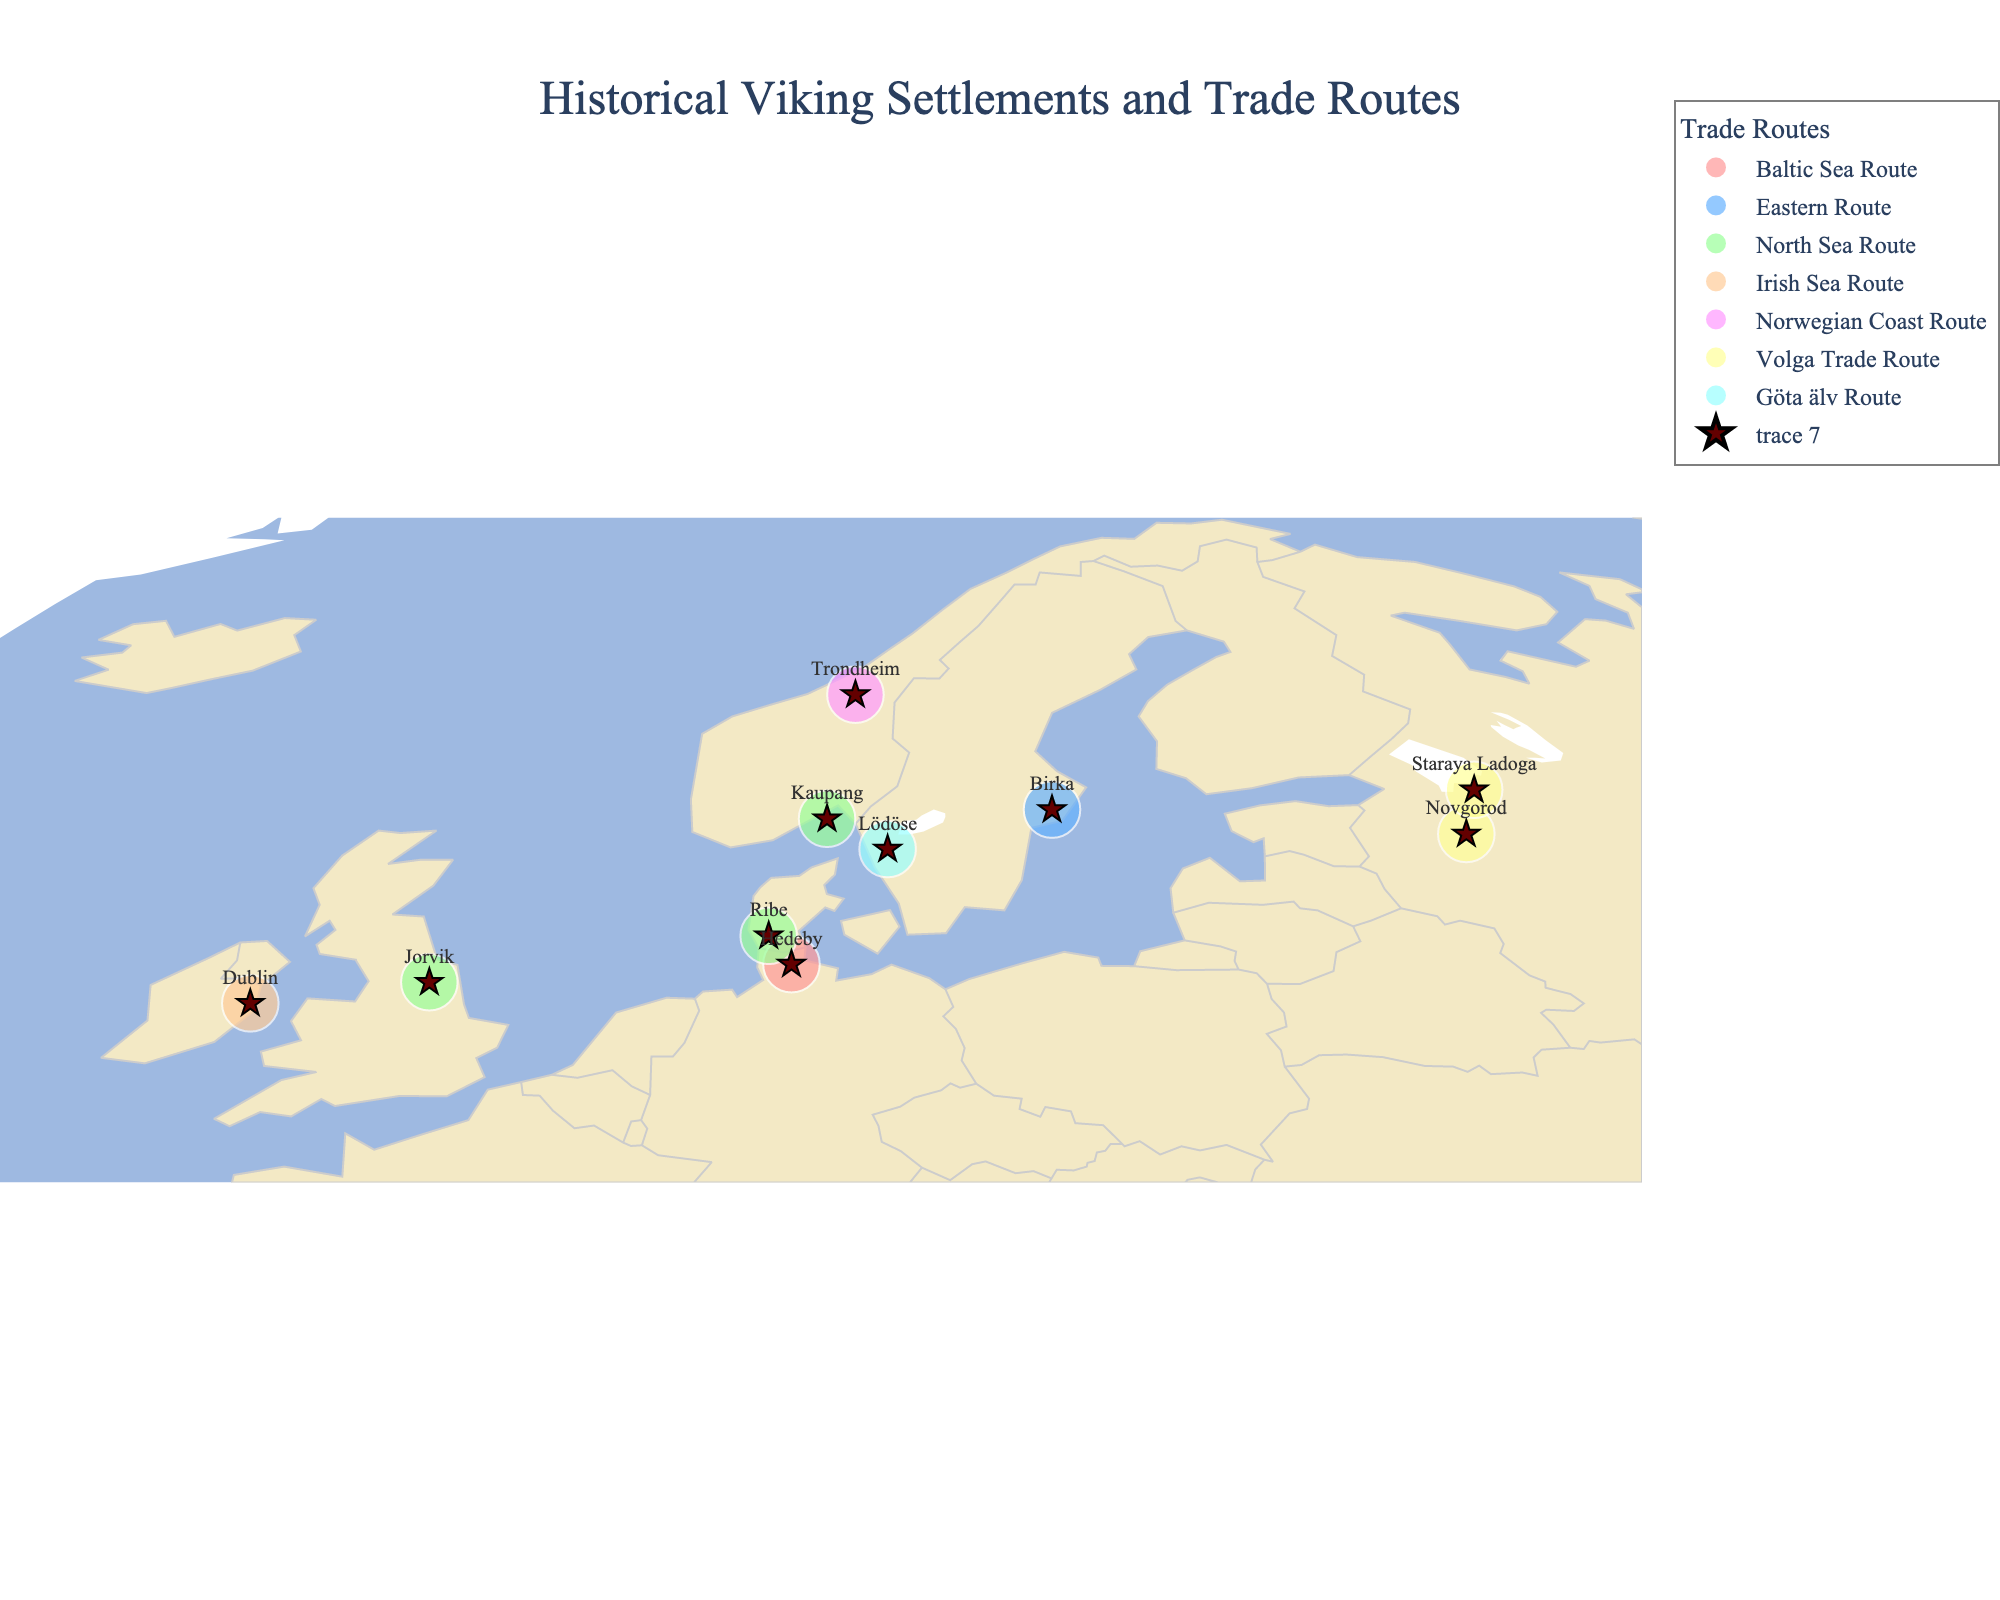What is the title of the figure? The title of the figure is located at the top center of the map. It reads "Historical Viking Settlements and Trade Routes."
Answer: Historical Viking Settlements and Trade Routes Which settlement is associated with the Baltic Sea Route? By examining the figure and looking for the color linked to the Baltic Sea Route in the legend, which is a shade of pink, we find that the settlement associated with this route is Hedeby.
Answer: Hedeby How many settlements are part of the North Sea Route? By referring to the figure and identifying the green-colored points representing the North Sea Route on the map, there are three such settlements: Kaupang, Jorvik, and Ribe.
Answer: Three Which settlement is furthest north and what trade route does it belong to? From the geographic coordinates on the map, the furthest north settlement is Trondheim. The legend indicates that it is part of the Norwegian Coast Route.
Answer: Trondheim, Norwegian Coast Route What was Dublin's main export according to the figure? Examining the hover information on the settlement Dublin, the main export listed for Dublin is Slaves.
Answer: Slaves Which settlements are part of the Volga Trade Route and what are their main exports? By looking at the legend for the color representing the Volga Trade Route (a light yellow), and then identifying the corresponding settlements on the map, we find Novgorod (Honey) and Staraya Ladoga (Walrus Ivory).
Answer: Novgorod (Honey), Staraya Ladoga (Walrus Ivory) Comparing Jorvik and Ribe, which settlement is further west? By referring to the longitude values on the map, Jorvik has a longitude closer to the western edge of the map than Ribe, placing it further west.
Answer: Jorvik What are the different trade routes shown in the figure? The figure legend lists the distinct trade routes, which include the Baltic Sea Route, Eastern Route, North Sea Route, Irish Sea Route, Norwegian Coast Route, Volga Trade Route, and Göta älv Route.
Answer: Baltic Sea Route, Eastern Route, North Sea Route, Irish Sea Route, Norwegian Coast Route, Volga Trade Route, Göta älv Route Which settlement trades Iron, and which route is it part of? Using the hover tool or examining the figure closely, Kaupang is identified as trading Iron and it is part of the North Sea Route, as indicated by the green color.
Answer: Kaupang, North Sea Route 